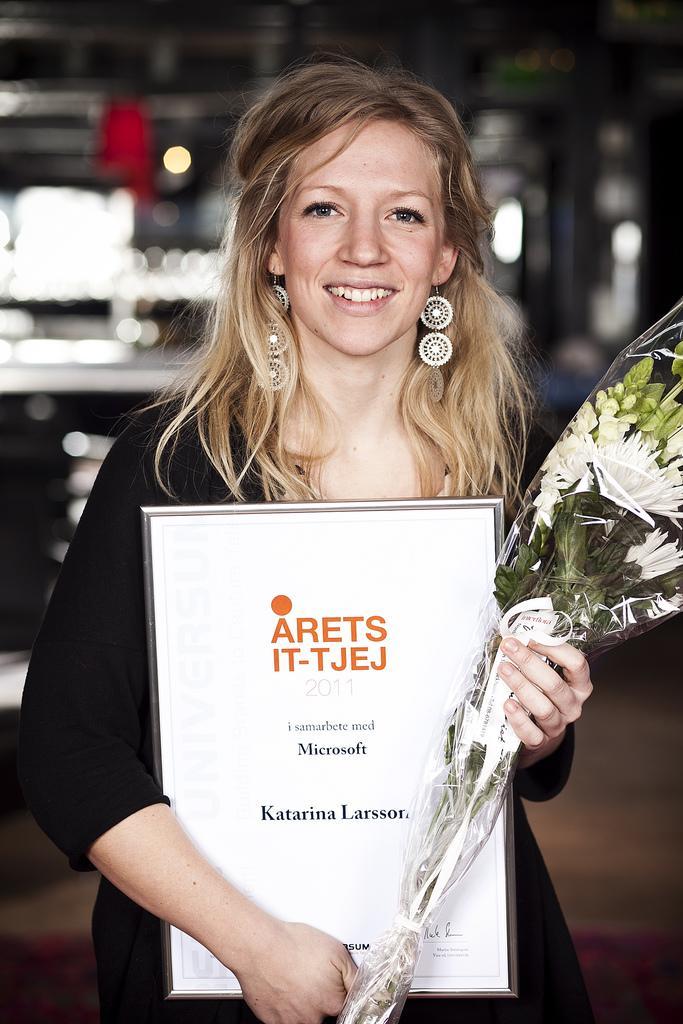How would you summarize this image in a sentence or two? In this image I can see the person is holding the frame and bouquet. I can see few objects and the blurred background. 